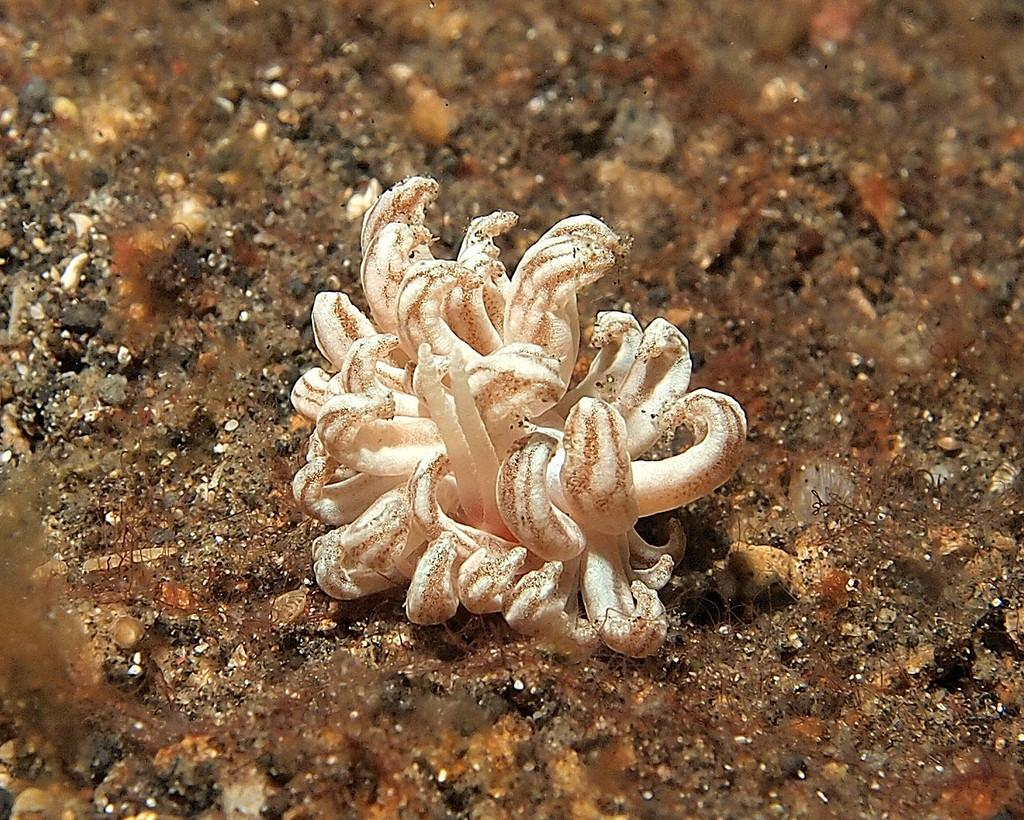What type of objects are on the ground in the image? There are white phallales on the ground in the image. Can you describe anything on the left side of the image? There might be small stones on the left side of the image. What type of health advice can be seen in the image? There is no health advice present in the image; it features white phallales on the ground and possibly small stones on the left side. What type of noise can be heard coming from the image? There is no sound or noise present in the image, as it is a still photograph. 